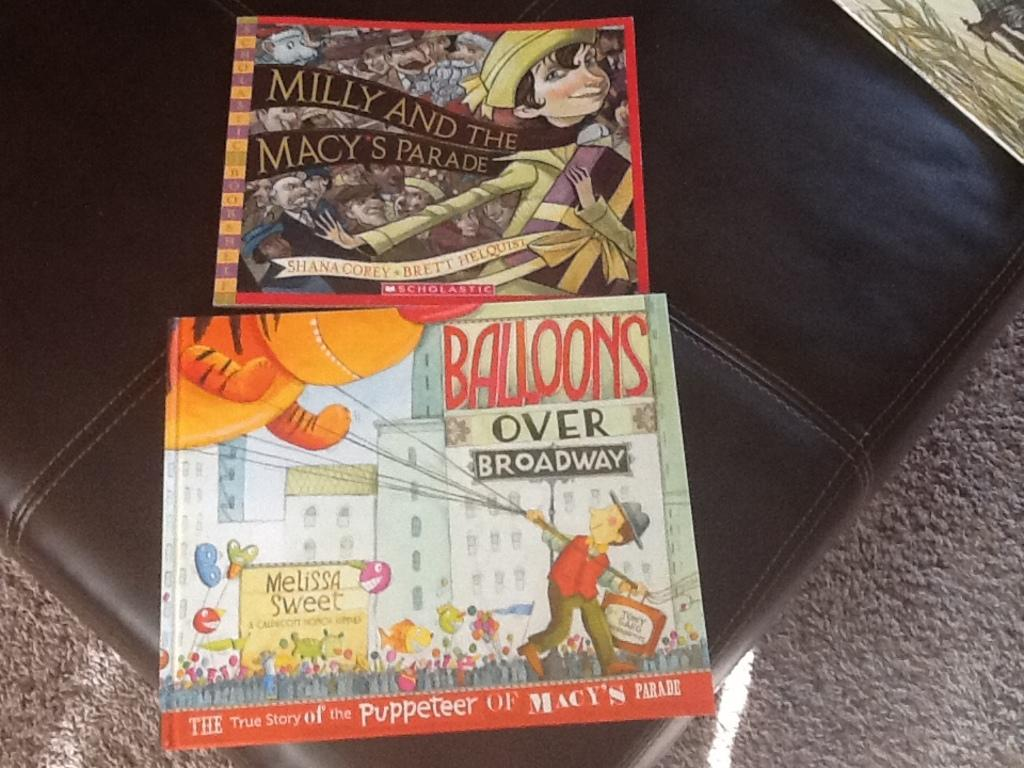<image>
Write a terse but informative summary of the picture. A book titled Balloons over Broadway sits on a couch. 